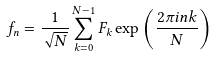Convert formula to latex. <formula><loc_0><loc_0><loc_500><loc_500>f _ { n } = \frac { 1 } { \sqrt { N } } \sum _ { k = 0 } ^ { N - 1 } F _ { k } \exp \left ( \frac { 2 \pi i n k } { N } \right )</formula> 